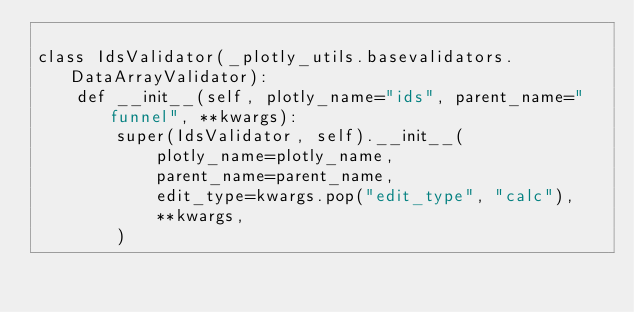<code> <loc_0><loc_0><loc_500><loc_500><_Python_>
class IdsValidator(_plotly_utils.basevalidators.DataArrayValidator):
    def __init__(self, plotly_name="ids", parent_name="funnel", **kwargs):
        super(IdsValidator, self).__init__(
            plotly_name=plotly_name,
            parent_name=parent_name,
            edit_type=kwargs.pop("edit_type", "calc"),
            **kwargs,
        )
</code> 